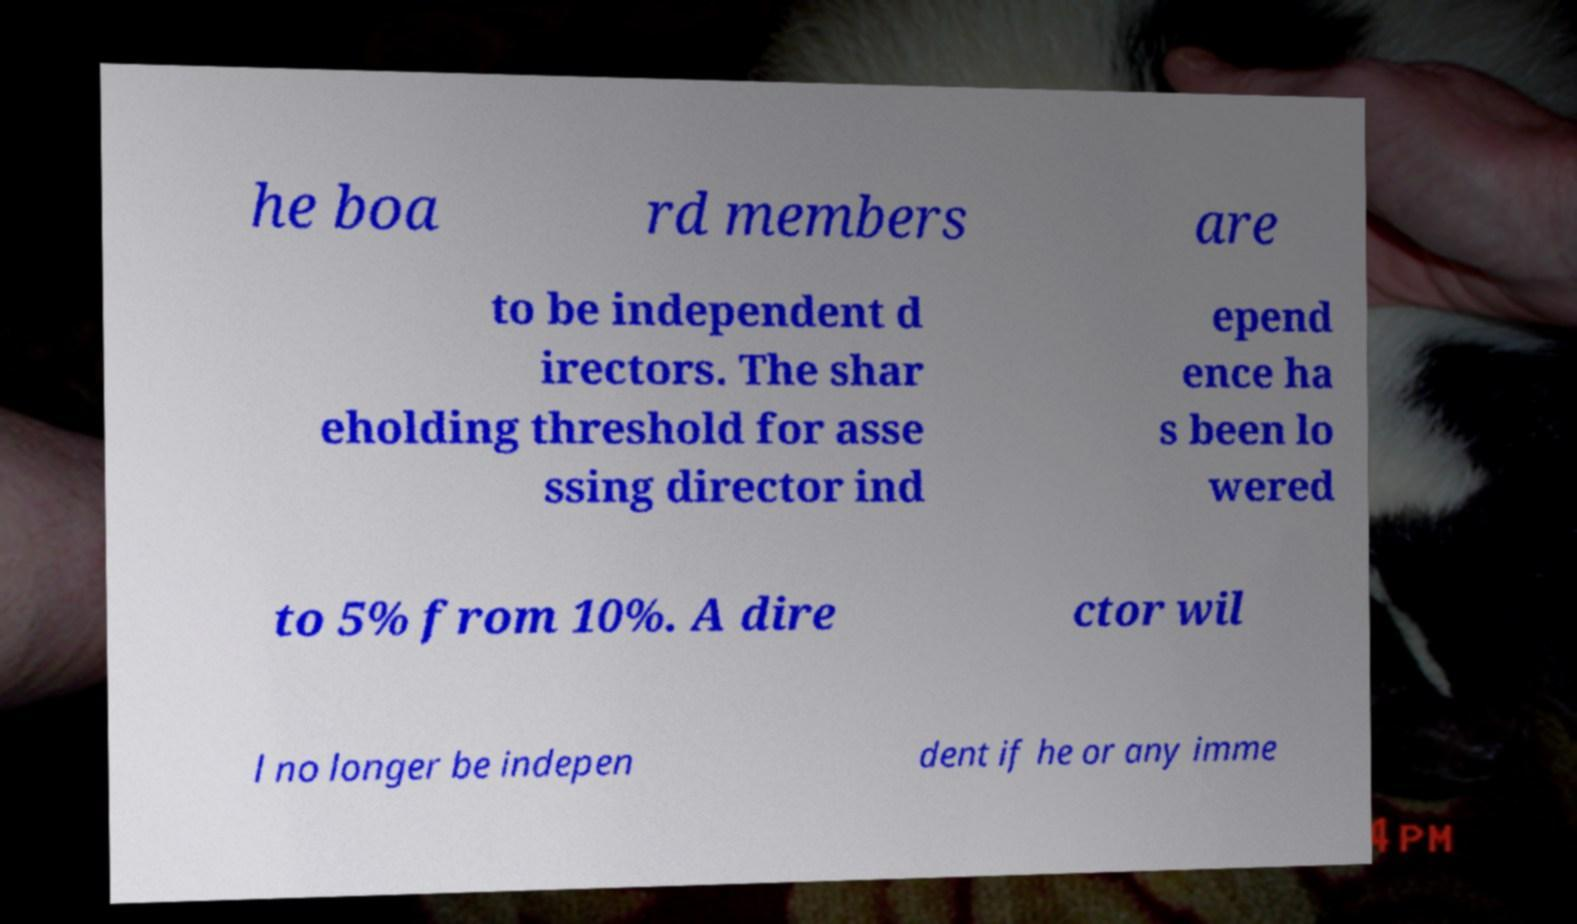Please identify and transcribe the text found in this image. he boa rd members are to be independent d irectors. The shar eholding threshold for asse ssing director ind epend ence ha s been lo wered to 5% from 10%. A dire ctor wil l no longer be indepen dent if he or any imme 